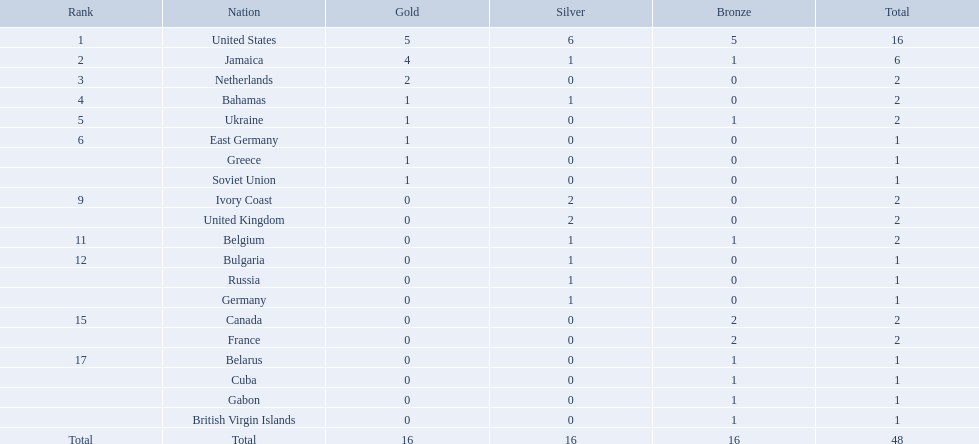What was the largest number of medals won by any country? 16. Which country won that many medals? United States. Could you help me parse every detail presented in this table? {'header': ['Rank', 'Nation', 'Gold', 'Silver', 'Bronze', 'Total'], 'rows': [['1', 'United States', '5', '6', '5', '16'], ['2', 'Jamaica', '4', '1', '1', '6'], ['3', 'Netherlands', '2', '0', '0', '2'], ['4', 'Bahamas', '1', '1', '0', '2'], ['5', 'Ukraine', '1', '0', '1', '2'], ['6', 'East Germany', '1', '0', '0', '1'], ['', 'Greece', '1', '0', '0', '1'], ['', 'Soviet Union', '1', '0', '0', '1'], ['9', 'Ivory Coast', '0', '2', '0', '2'], ['', 'United Kingdom', '0', '2', '0', '2'], ['11', 'Belgium', '0', '1', '1', '2'], ['12', 'Bulgaria', '0', '1', '0', '1'], ['', 'Russia', '0', '1', '0', '1'], ['', 'Germany', '0', '1', '0', '1'], ['15', 'Canada', '0', '0', '2', '2'], ['', 'France', '0', '0', '2', '2'], ['17', 'Belarus', '0', '0', '1', '1'], ['', 'Cuba', '0', '0', '1', '1'], ['', 'Gabon', '0', '0', '1', '1'], ['', 'British Virgin Islands', '0', '0', '1', '1'], ['Total', 'Total', '16', '16', '16', '48']]} Parse the full table in json format. {'header': ['Rank', 'Nation', 'Gold', 'Silver', 'Bronze', 'Total'], 'rows': [['1', 'United States', '5', '6', '5', '16'], ['2', 'Jamaica', '4', '1', '1', '6'], ['3', 'Netherlands', '2', '0', '0', '2'], ['4', 'Bahamas', '1', '1', '0', '2'], ['5', 'Ukraine', '1', '0', '1', '2'], ['6', 'East Germany', '1', '0', '0', '1'], ['', 'Greece', '1', '0', '0', '1'], ['', 'Soviet Union', '1', '0', '0', '1'], ['9', 'Ivory Coast', '0', '2', '0', '2'], ['', 'United Kingdom', '0', '2', '0', '2'], ['11', 'Belgium', '0', '1', '1', '2'], ['12', 'Bulgaria', '0', '1', '0', '1'], ['', 'Russia', '0', '1', '0', '1'], ['', 'Germany', '0', '1', '0', '1'], ['15', 'Canada', '0', '0', '2', '2'], ['', 'France', '0', '0', '2', '2'], ['17', 'Belarus', '0', '0', '1', '1'], ['', 'Cuba', '0', '0', '1', '1'], ['', 'Gabon', '0', '0', '1', '1'], ['', 'British Virgin Islands', '0', '0', '1', '1'], ['Total', 'Total', '16', '16', '16', '48']]} Which nations took home at least one gold medal in the 60 metres competition? United States, Jamaica, Netherlands, Bahamas, Ukraine, East Germany, Greece, Soviet Union. Of these nations, which one won the most gold medals? United States. Which countries competed in the 60 meters competition? United States, Jamaica, Netherlands, Bahamas, Ukraine, East Germany, Greece, Soviet Union, Ivory Coast, United Kingdom, Belgium, Bulgaria, Russia, Germany, Canada, France, Belarus, Cuba, Gabon, British Virgin Islands. And how many gold medals did they win? 5, 4, 2, 1, 1, 1, 1, 1, 0, 0, 0, 0, 0, 0, 0, 0, 0, 0, 0, 0. Could you parse the entire table as a dict? {'header': ['Rank', 'Nation', 'Gold', 'Silver', 'Bronze', 'Total'], 'rows': [['1', 'United States', '5', '6', '5', '16'], ['2', 'Jamaica', '4', '1', '1', '6'], ['3', 'Netherlands', '2', '0', '0', '2'], ['4', 'Bahamas', '1', '1', '0', '2'], ['5', 'Ukraine', '1', '0', '1', '2'], ['6', 'East Germany', '1', '0', '0', '1'], ['', 'Greece', '1', '0', '0', '1'], ['', 'Soviet Union', '1', '0', '0', '1'], ['9', 'Ivory Coast', '0', '2', '0', '2'], ['', 'United Kingdom', '0', '2', '0', '2'], ['11', 'Belgium', '0', '1', '1', '2'], ['12', 'Bulgaria', '0', '1', '0', '1'], ['', 'Russia', '0', '1', '0', '1'], ['', 'Germany', '0', '1', '0', '1'], ['15', 'Canada', '0', '0', '2', '2'], ['', 'France', '0', '0', '2', '2'], ['17', 'Belarus', '0', '0', '1', '1'], ['', 'Cuba', '0', '0', '1', '1'], ['', 'Gabon', '0', '0', '1', '1'], ['', 'British Virgin Islands', '0', '0', '1', '1'], ['Total', 'Total', '16', '16', '16', '48']]} Of those countries, which won the second highest number gold medals? Jamaica. Would you mind parsing the complete table? {'header': ['Rank', 'Nation', 'Gold', 'Silver', 'Bronze', 'Total'], 'rows': [['1', 'United States', '5', '6', '5', '16'], ['2', 'Jamaica', '4', '1', '1', '6'], ['3', 'Netherlands', '2', '0', '0', '2'], ['4', 'Bahamas', '1', '1', '0', '2'], ['5', 'Ukraine', '1', '0', '1', '2'], ['6', 'East Germany', '1', '0', '0', '1'], ['', 'Greece', '1', '0', '0', '1'], ['', 'Soviet Union', '1', '0', '0', '1'], ['9', 'Ivory Coast', '0', '2', '0', '2'], ['', 'United Kingdom', '0', '2', '0', '2'], ['11', 'Belgium', '0', '1', '1', '2'], ['12', 'Bulgaria', '0', '1', '0', '1'], ['', 'Russia', '0', '1', '0', '1'], ['', 'Germany', '0', '1', '0', '1'], ['15', 'Canada', '0', '0', '2', '2'], ['', 'France', '0', '0', '2', '2'], ['17', 'Belarus', '0', '0', '1', '1'], ['', 'Cuba', '0', '0', '1', '1'], ['', 'Gabon', '0', '0', '1', '1'], ['', 'British Virgin Islands', '0', '0', '1', '1'], ['Total', 'Total', '16', '16', '16', '48']]} Which nations obtained at least one gold medal in the 60 meters contest? United States, Jamaica, Netherlands, Bahamas, Ukraine, East Germany, Greece, Soviet Union. From these nations, which one claimed the maximum gold medals? United States. What nations participated? United States, Jamaica, Netherlands, Bahamas, Ukraine, East Germany, Greece, Soviet Union, Ivory Coast, United Kingdom, Belgium, Bulgaria, Russia, Germany, Canada, France, Belarus, Cuba, Gabon, British Virgin Islands. Which nations secured gold medals? United States, Jamaica, Netherlands, Bahamas, Ukraine, East Germany, Greece, Soviet Union. Which nation had the second highest number of medals? Jamaica. In the 60 meters race, which countries took part? United States, Jamaica, Netherlands, Bahamas, Ukraine, East Germany, Greece, Soviet Union, Ivory Coast, United Kingdom, Belgium, Bulgaria, Russia, Germany, Canada, France, Belarus, Cuba, Gabon, British Virgin Islands. And how many gold medals did they obtain? 5, 4, 2, 1, 1, 1, 1, 1, 0, 0, 0, 0, 0, 0, 0, 0, 0, 0, 0, 0. Among these countries, which got the second greatest number of gold medals? Jamaica. Which nations took part? United States, Jamaica, Netherlands, Bahamas, Ukraine, East Germany, Greece, Soviet Union, Ivory Coast, United Kingdom, Belgium, Bulgaria, Russia, Germany, Canada, France, Belarus, Cuba, Gabon, British Virgin Islands. How many gold awards did each achieve? 5, 4, 2, 1, 1, 1, 1, 1, 0, 0, 0, 0, 0, 0, 0, 0, 0, 0, 0, 0. And which nation secured the most? United States. Which country obtained the most medals? United States. How many medals did the us capture? 16. What is the maximum amount of medals (after 16) that were secured by a country? 6. Which country claimed 6 medals? Jamaica. Write the full table. {'header': ['Rank', 'Nation', 'Gold', 'Silver', 'Bronze', 'Total'], 'rows': [['1', 'United States', '5', '6', '5', '16'], ['2', 'Jamaica', '4', '1', '1', '6'], ['3', 'Netherlands', '2', '0', '0', '2'], ['4', 'Bahamas', '1', '1', '0', '2'], ['5', 'Ukraine', '1', '0', '1', '2'], ['6', 'East Germany', '1', '0', '0', '1'], ['', 'Greece', '1', '0', '0', '1'], ['', 'Soviet Union', '1', '0', '0', '1'], ['9', 'Ivory Coast', '0', '2', '0', '2'], ['', 'United Kingdom', '0', '2', '0', '2'], ['11', 'Belgium', '0', '1', '1', '2'], ['12', 'Bulgaria', '0', '1', '0', '1'], ['', 'Russia', '0', '1', '0', '1'], ['', 'Germany', '0', '1', '0', '1'], ['15', 'Canada', '0', '0', '2', '2'], ['', 'France', '0', '0', '2', '2'], ['17', 'Belarus', '0', '0', '1', '1'], ['', 'Cuba', '0', '0', '1', '1'], ['', 'Gabon', '0', '0', '1', '1'], ['', 'British Virgin Islands', '0', '0', '1', '1'], ['Total', 'Total', '16', '16', '16', '48']]} Which countries were involved in the 60 meters event? United States, Jamaica, Netherlands, Bahamas, Ukraine, East Germany, Greece, Soviet Union, Ivory Coast, United Kingdom, Belgium, Bulgaria, Russia, Germany, Canada, France, Belarus, Cuba, Gabon, British Virgin Islands. And how many gold medals did they achieve? 5, 4, 2, 1, 1, 1, 1, 1, 0, 0, 0, 0, 0, 0, 0, 0, 0, 0, 0, 0. From those countries, which one won the second highest quantity of gold medals? Jamaica. What nation claimed the most medals? United States. How many medals did the us secure? 16. What is the greatest number of medals (after 16) that were claimed by a nation? 6. Which nation captured 6 medals? Jamaica. Which countries secured a minimum of one gold medal in the 60 meters event? United States, Jamaica, Netherlands, Bahamas, Ukraine, East Germany, Greece, Soviet Union. Among these countries, which one achieved the highest number of gold medals? United States. Which nations participated? United States, Jamaica, Netherlands, Bahamas, Ukraine, East Germany, Greece, Soviet Union, Ivory Coast, United Kingdom, Belgium, Bulgaria, Russia, Germany, Canada, France, Belarus, Cuba, Gabon, British Virgin Islands. Which nations secured gold medals? United States, Jamaica, Netherlands, Bahamas, Ukraine, East Germany, Greece, Soviet Union. Which nation ranked second in terms of total medals? Jamaica. What were the competing countries? United States, Jamaica, Netherlands, Bahamas, Ukraine, East Germany, Greece, Soviet Union, Ivory Coast, United Kingdom, Belgium, Bulgaria, Russia, Germany, Canada, France, Belarus, Cuba, Gabon, British Virgin Islands. Which countries earned gold medals? United States, Jamaica, Netherlands, Bahamas, Ukraine, East Germany, Greece, Soviet Union. Which country came in second place for overall medals? Jamaica. Which countries took part in the competition? United States, Jamaica, Netherlands, Bahamas, Ukraine, East Germany, Greece, Soviet Union, Ivory Coast, United Kingdom, Belgium, Bulgaria, Russia, Germany, Canada, France, Belarus, Cuba, Gabon, British Virgin Islands. Which countries claimed gold medals? United States, Jamaica, Netherlands, Bahamas, Ukraine, East Germany, Greece, Soviet Union. Which country had the runner-up position in terms of total medals? Jamaica. 